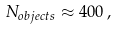Convert formula to latex. <formula><loc_0><loc_0><loc_500><loc_500>N _ { o b j e c t s } \approx 4 0 0 \, ,</formula> 